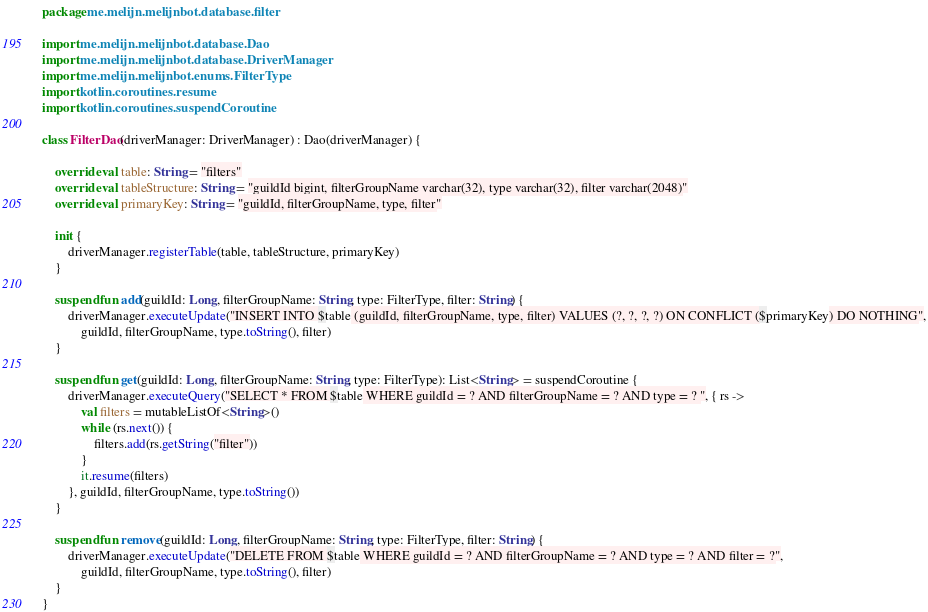Convert code to text. <code><loc_0><loc_0><loc_500><loc_500><_Kotlin_>package me.melijn.melijnbot.database.filter

import me.melijn.melijnbot.database.Dao
import me.melijn.melijnbot.database.DriverManager
import me.melijn.melijnbot.enums.FilterType
import kotlin.coroutines.resume
import kotlin.coroutines.suspendCoroutine

class FilterDao(driverManager: DriverManager) : Dao(driverManager) {

    override val table: String = "filters"
    override val tableStructure: String = "guildId bigint, filterGroupName varchar(32), type varchar(32), filter varchar(2048)"
    override val primaryKey: String = "guildId, filterGroupName, type, filter"

    init {
        driverManager.registerTable(table, tableStructure, primaryKey)
    }

    suspend fun add(guildId: Long, filterGroupName: String, type: FilterType, filter: String) {
        driverManager.executeUpdate("INSERT INTO $table (guildId, filterGroupName, type, filter) VALUES (?, ?, ?, ?) ON CONFLICT ($primaryKey) DO NOTHING",
            guildId, filterGroupName, type.toString(), filter)
    }

    suspend fun get(guildId: Long, filterGroupName: String, type: FilterType): List<String> = suspendCoroutine {
        driverManager.executeQuery("SELECT * FROM $table WHERE guildId = ? AND filterGroupName = ? AND type = ? ", { rs ->
            val filters = mutableListOf<String>()
            while (rs.next()) {
                filters.add(rs.getString("filter"))
            }
            it.resume(filters)
        }, guildId, filterGroupName, type.toString())
    }

    suspend fun remove(guildId: Long, filterGroupName: String, type: FilterType, filter: String) {
        driverManager.executeUpdate("DELETE FROM $table WHERE guildId = ? AND filterGroupName = ? AND type = ? AND filter = ?",
            guildId, filterGroupName, type.toString(), filter)
    }
}</code> 